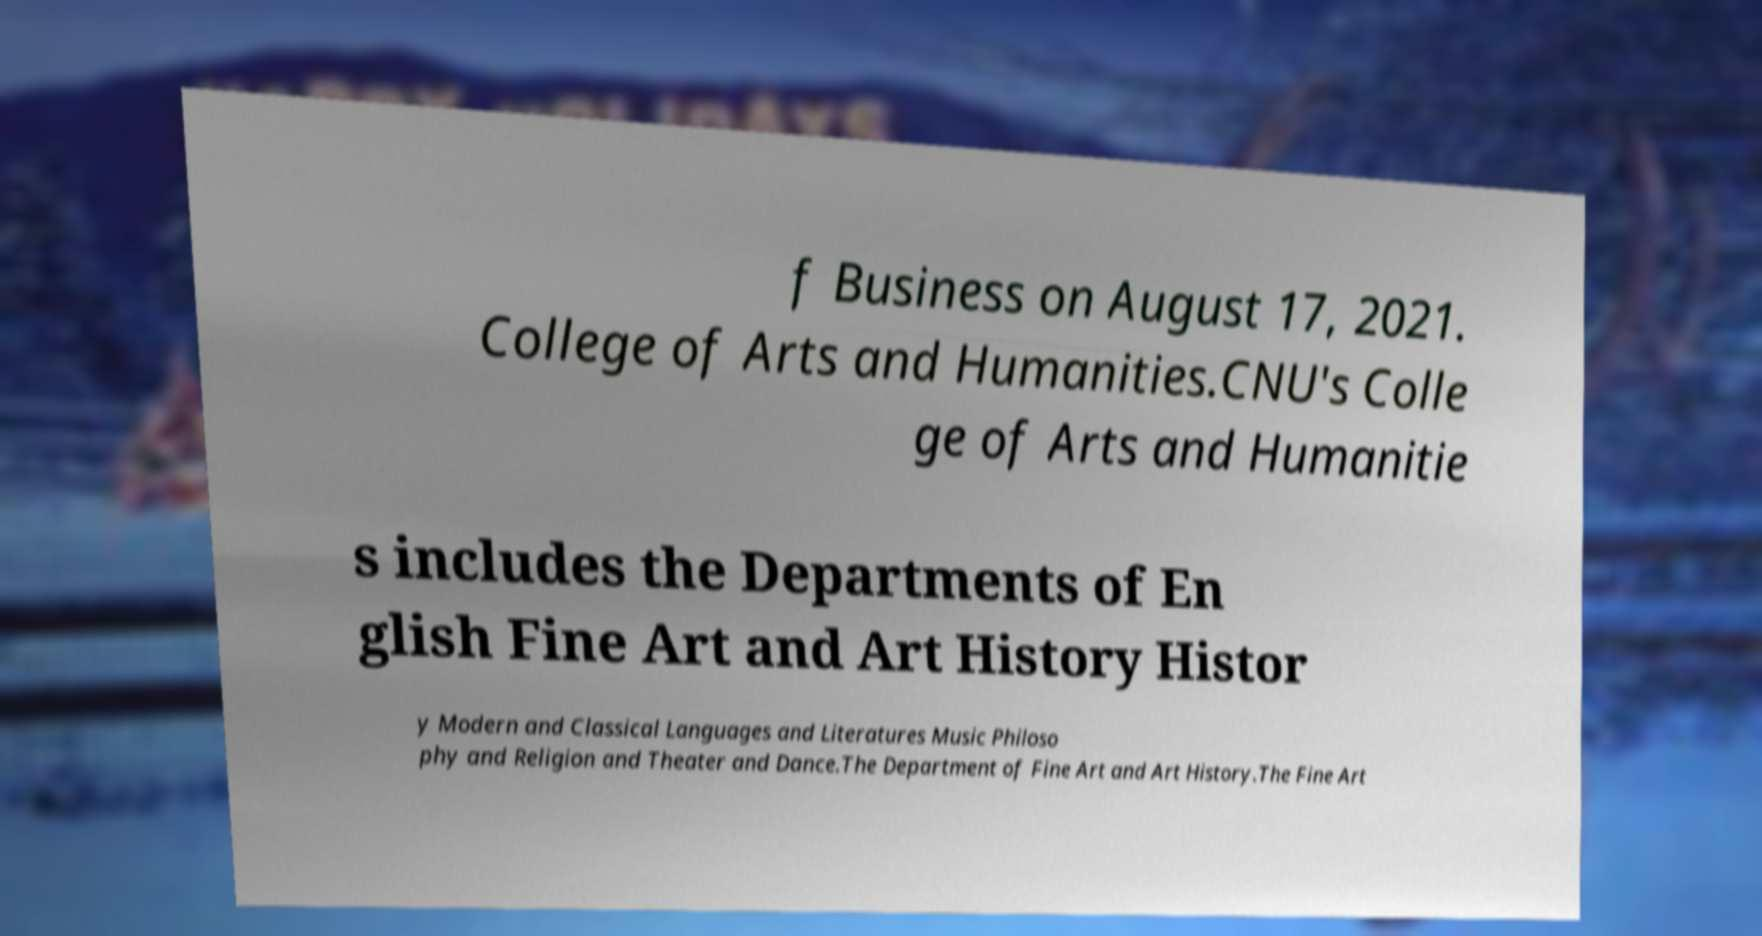There's text embedded in this image that I need extracted. Can you transcribe it verbatim? f Business on August 17, 2021. College of Arts and Humanities.CNU's Colle ge of Arts and Humanitie s includes the Departments of En glish Fine Art and Art History Histor y Modern and Classical Languages and Literatures Music Philoso phy and Religion and Theater and Dance.The Department of Fine Art and Art History.The Fine Art 